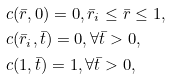Convert formula to latex. <formula><loc_0><loc_0><loc_500><loc_500>& c ( \bar { r } , 0 ) = 0 , \bar { r } _ { i } \leq \bar { r } \leq 1 , \\ & c ( \bar { r } _ { i } , \bar { t } ) = 0 , \forall \bar { t } > 0 , \\ & c ( 1 , \bar { t } ) = 1 , \forall \bar { t } > 0 ,</formula> 